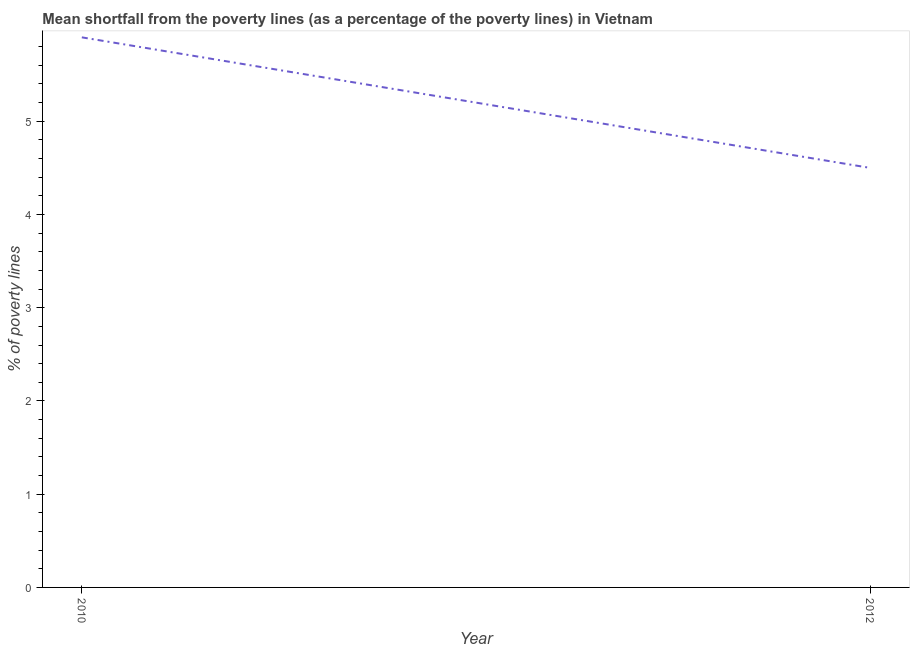What is the poverty gap at national poverty lines in 2012?
Provide a succinct answer. 4.5. Across all years, what is the minimum poverty gap at national poverty lines?
Offer a terse response. 4.5. In which year was the poverty gap at national poverty lines maximum?
Provide a short and direct response. 2010. In which year was the poverty gap at national poverty lines minimum?
Your response must be concise. 2012. What is the sum of the poverty gap at national poverty lines?
Ensure brevity in your answer.  10.4. What is the difference between the poverty gap at national poverty lines in 2010 and 2012?
Your answer should be very brief. 1.4. What is the average poverty gap at national poverty lines per year?
Keep it short and to the point. 5.2. What is the median poverty gap at national poverty lines?
Provide a short and direct response. 5.2. In how many years, is the poverty gap at national poverty lines greater than 1.6 %?
Provide a short and direct response. 2. What is the ratio of the poverty gap at national poverty lines in 2010 to that in 2012?
Your answer should be very brief. 1.31. Is the poverty gap at national poverty lines in 2010 less than that in 2012?
Offer a very short reply. No. Does the poverty gap at national poverty lines monotonically increase over the years?
Provide a short and direct response. No. How many lines are there?
Provide a succinct answer. 1. How many years are there in the graph?
Give a very brief answer. 2. What is the difference between two consecutive major ticks on the Y-axis?
Ensure brevity in your answer.  1. Are the values on the major ticks of Y-axis written in scientific E-notation?
Your response must be concise. No. Does the graph contain any zero values?
Keep it short and to the point. No. What is the title of the graph?
Offer a terse response. Mean shortfall from the poverty lines (as a percentage of the poverty lines) in Vietnam. What is the label or title of the X-axis?
Your answer should be compact. Year. What is the label or title of the Y-axis?
Keep it short and to the point. % of poverty lines. What is the ratio of the % of poverty lines in 2010 to that in 2012?
Offer a very short reply. 1.31. 